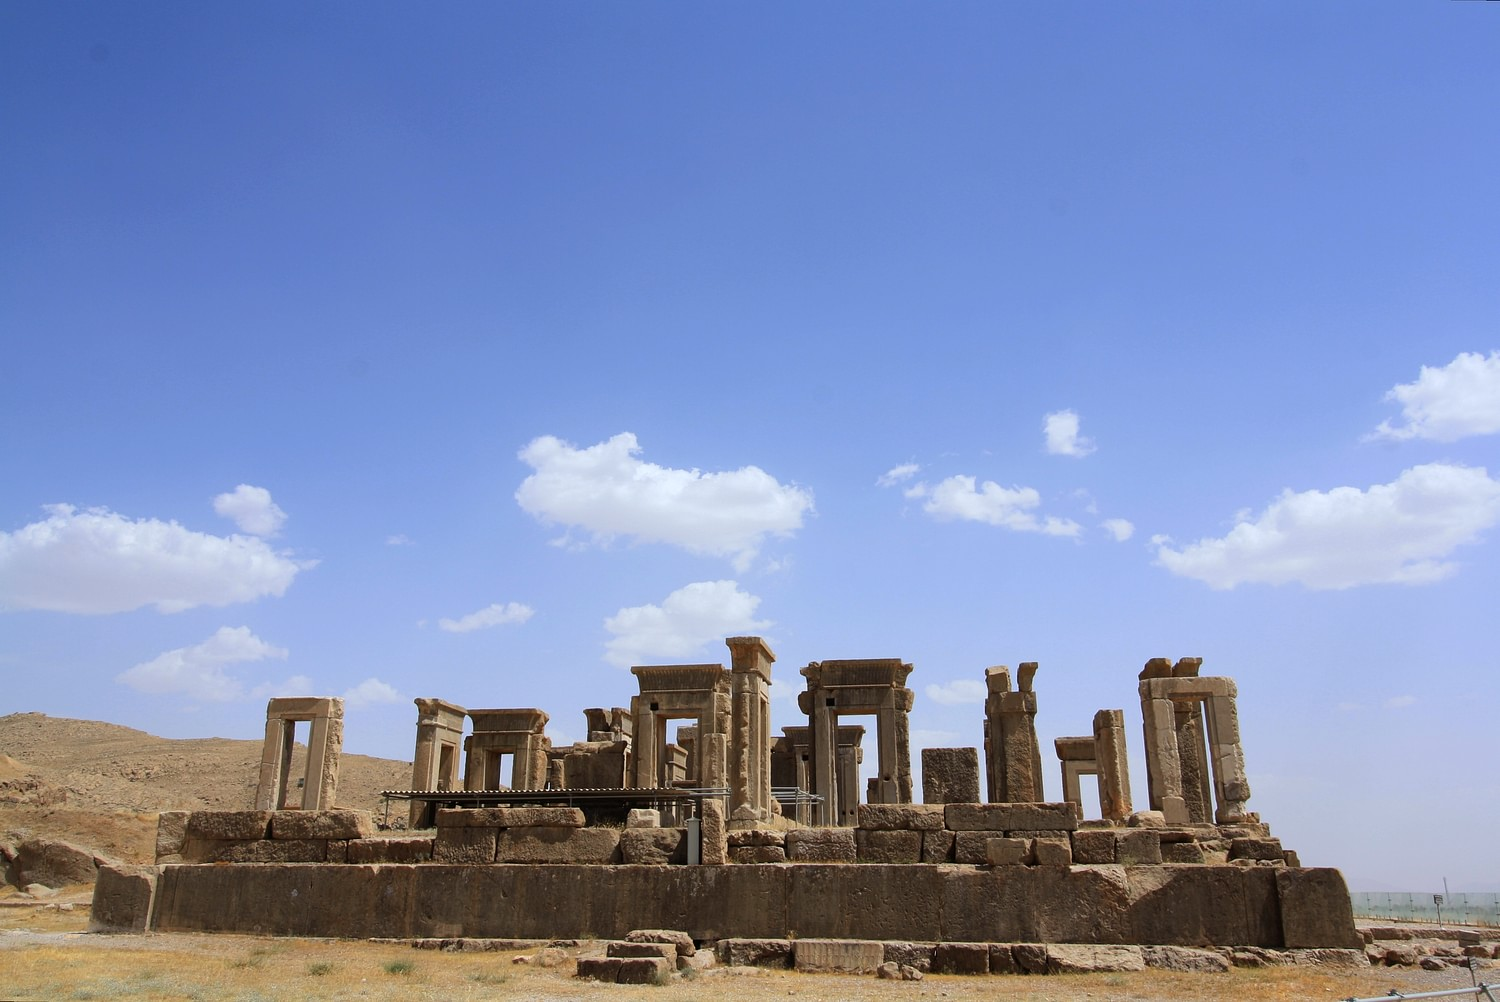What do you think is going on in this snapshot? This image captures the imposing ancient ruins of Persepolis in Iran. These ruins are from the ceremonial capital of the Achaemenid Empire, showcasing intricate stone carvings and majestic columns. Founded by Darius I in 518 B.C., Persepolis was a symbol of the empire's power and sophistication. Each column and statue tells a story of past glories, royal ceremonies, and the rich cultural tapestry of ancient Persian civilization. The clear blue sky and rugged mountainous backdrop highlight the site's dramatic and strategic setting, enabling a glimpse into a bygone era when this site was a hub of political and spiritual life. 